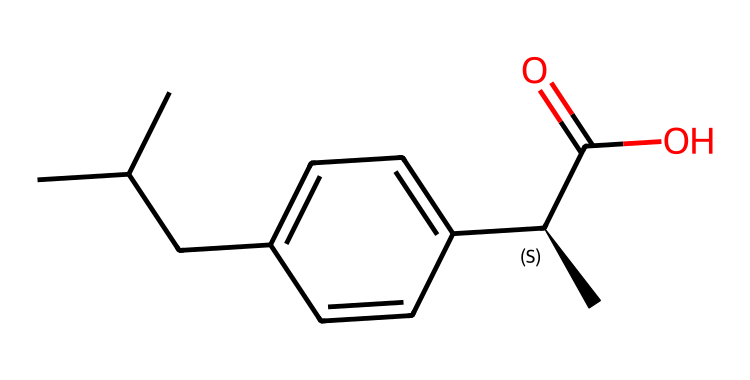What is the name of this chemical? The chemical structure represents ibuprofen, a nonsteroidal anti-inflammatory drug. The name can be derived from the chemical structure shown in the SMILES representation.
Answer: ibuprofen How many carbon atoms are in the structure? By analyzing the SMILES string, we can count that there are 13 carbon atoms labeled in the structure (each 'C' corresponds to a carbon atom in the chain and rings).
Answer: 13 What functional group is present in ibuprofen? In the SMILES representation, the presence of the 'C(=O)O' at the end indicates the presence of a carboxylic acid functional group, which is characteristic for ibuprofen.
Answer: carboxylic acid Is this molecule saturated or unsaturated? The presence of double bonds or single bonds in the structure needs to be assessed. In this case, no double bonds are explicitly visible in the main carbon framework, indicating it's a saturated compound.
Answer: saturated What is the stereochemistry at the chiral center? The 'C@' in the SMILES highlights the presence of one chiral center, which indicates that the molecule has a specific stereochemistry. The specific configuration would need to be determined based on additional data but is generally R or S, based on its spatial arrangement.
Answer: chiral center How many benzene rings does ibuprofen contain? By examining the structure, there is one benzene ring present within the overall molecular structure, identified by the 'cc' sequences within the 'c' characters.
Answer: 1 What type of hydrocarbon is ibuprofen categorized as? Since ibuprofen contains both carbon and hydrogen, along with functional groups, it is classified as an aromatic hydrocarbon due to the benzene ring structure.
Answer: aromatic hydrocarbon 